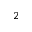Convert formula to latex. <formula><loc_0><loc_0><loc_500><loc_500>_ { 2 }</formula> 